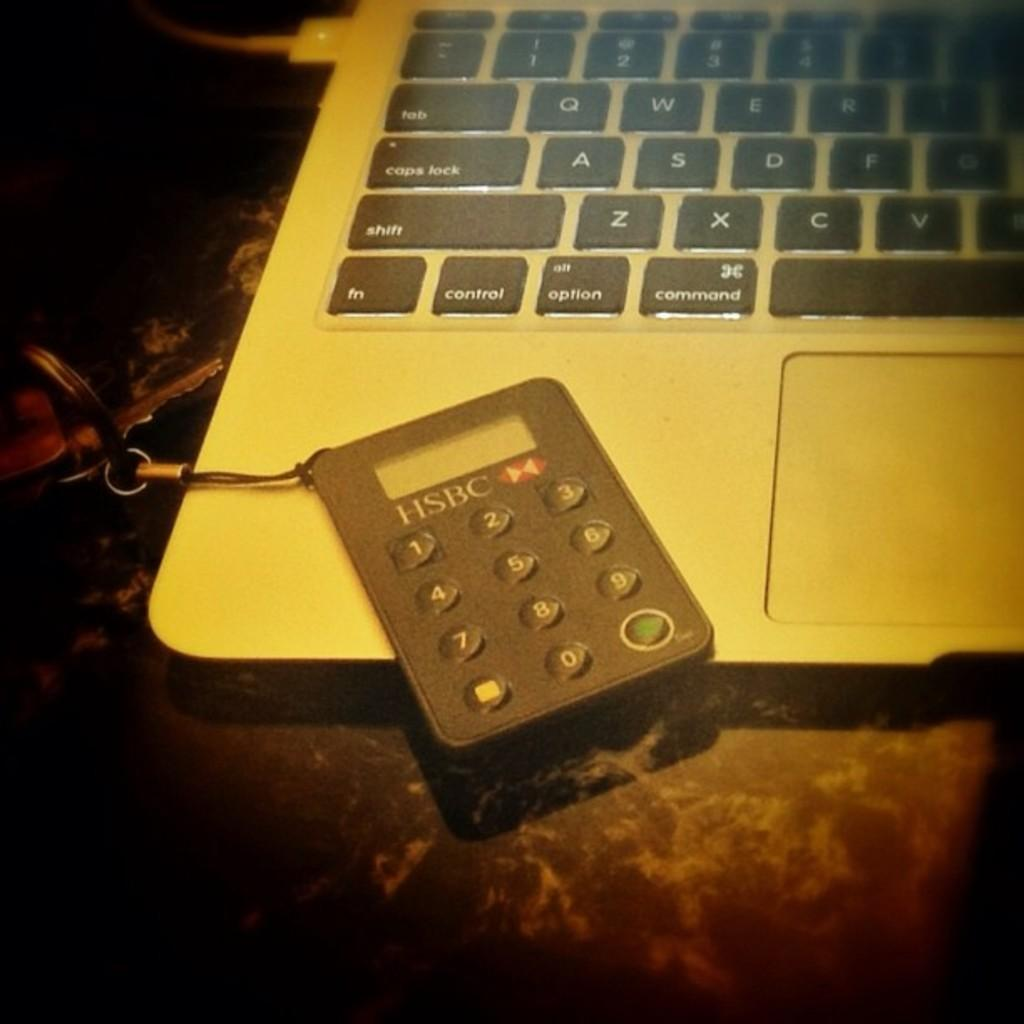<image>
Describe the image concisely. An HSBC branded calculator on top of a laptop computer. 